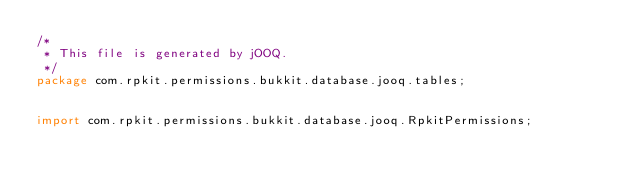Convert code to text. <code><loc_0><loc_0><loc_500><loc_500><_Java_>/*
 * This file is generated by jOOQ.
 */
package com.rpkit.permissions.bukkit.database.jooq.tables;


import com.rpkit.permissions.bukkit.database.jooq.RpkitPermissions;</code> 